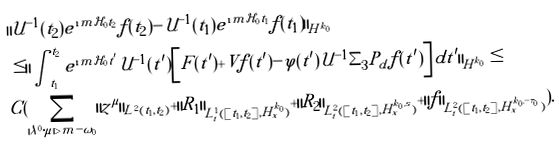Convert formula to latex. <formula><loc_0><loc_0><loc_500><loc_500>& \| \mathcal { U } ^ { - 1 } ( t _ { 2 } ) e ^ { \i m \mathcal { H } _ { 0 } t _ { 2 } } f ( t _ { 2 } ) - \mathcal { U } ^ { - 1 } ( t _ { 1 } ) e ^ { \i m \mathcal { H } _ { 0 } t _ { 1 } } f ( t _ { 1 } ) \| _ { H ^ { k _ { 0 } } } \\ & \leq \| \int _ { t _ { 1 } } ^ { t _ { 2 } } e ^ { \i m \mathcal { H } _ { 0 } t ^ { \prime } } \mathcal { U } ^ { - 1 } ( t ^ { \prime } ) \left [ F ( t ^ { \prime } ) + V f ( t ^ { \prime } ) - \varphi ( t ^ { \prime } ) \mathcal { U } ^ { - 1 } \Sigma _ { 3 } P _ { d } f ( t ^ { \prime } ) \right ] d t ^ { \prime } \| _ { H ^ { k _ { 0 } } } \leq \\ & C ( \sum _ { | \lambda ^ { 0 } \cdot \mu | > m - \omega _ { 0 } } \| z ^ { \mu } \| _ { L ^ { 2 } ( t _ { 1 } , t _ { 2 } ) } + \| R _ { 1 } \| _ { L ^ { 1 } _ { t } ( [ t _ { 1 } , t _ { 2 } ] , H ^ { k _ { 0 } } _ { x } ) } + \| R _ { 2 } \| _ { L ^ { 2 } _ { t } ( [ t _ { 1 } , t _ { 2 } ] , H ^ { k _ { 0 } , s } _ { x } ) } + \| f \| _ { L ^ { 2 } _ { t } ( [ t _ { 1 } , t _ { 2 } ] , H ^ { k _ { 0 } , - \tau _ { 0 } } _ { x } ) } ) .</formula> 